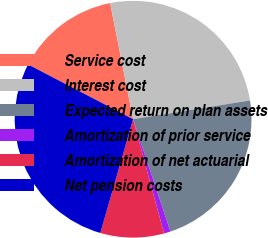<chart> <loc_0><loc_0><loc_500><loc_500><pie_chart><fcel>Service cost<fcel>Interest cost<fcel>Expected return on plan assets<fcel>Amortization of prior service<fcel>Amortization of net actuarial<fcel>Net pension costs<nl><fcel>14.25%<fcel>25.57%<fcel>22.42%<fcel>0.9%<fcel>8.67%<fcel>28.18%<nl></chart> 